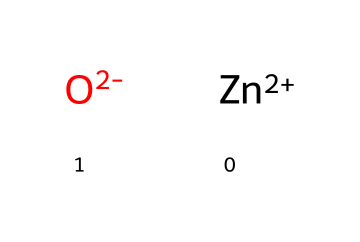What elements are present in zinc oxide? The SMILES representation shows the components as [Zn+2] and [O-2], indicating the presence of zinc (Zn) and oxygen (O) atoms.
Answer: zinc, oxygen How many atoms are there in zinc oxide? Analyzing the SMILES representation, there are two distinct atoms: one zinc atom and one oxygen atom, totaling two atoms in this chemical compound.
Answer: two What is the oxidation state of zinc in zinc oxide? The SMILES notation [Zn+2] indicates that zinc has a charge of +2, meaning its oxidation state in this compound is +2.
Answer: +2 What is the charge of the oxide ion in zinc oxide? The notation [O-2] indicates that the oxide ion has a charge of -2, which is characteristic of oxide in compounds with metals like zinc.
Answer: -2 Explain the reason zinc oxide is suitable for sunscreen. Zinc oxide is a compound that provides broad-spectrum protection against UV radiation due to its physical properties, primarily attributed to the zinc and oxide ions creating a barrier on the skin.
Answer: physical barrier What is the primary function of zinc oxide in topical applications? In topical applications, particularly in sunscreens, zinc oxide serves primarily as a sunblock agent, reflecting and scattering UV radiation to protect the skin.
Answer: sunblock agent Does zinc oxide dissolve in water? Zinc oxide is insoluble in water, which contributes to its effectiveness as a protective barrier in sunscreen formulations.
Answer: insoluble 